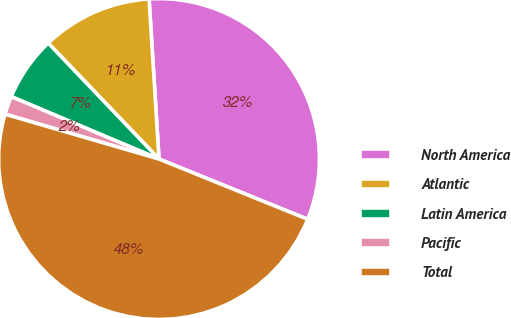<chart> <loc_0><loc_0><loc_500><loc_500><pie_chart><fcel>North America<fcel>Atlantic<fcel>Latin America<fcel>Pacific<fcel>Total<nl><fcel>32.11%<fcel>11.15%<fcel>6.5%<fcel>1.85%<fcel>48.38%<nl></chart> 